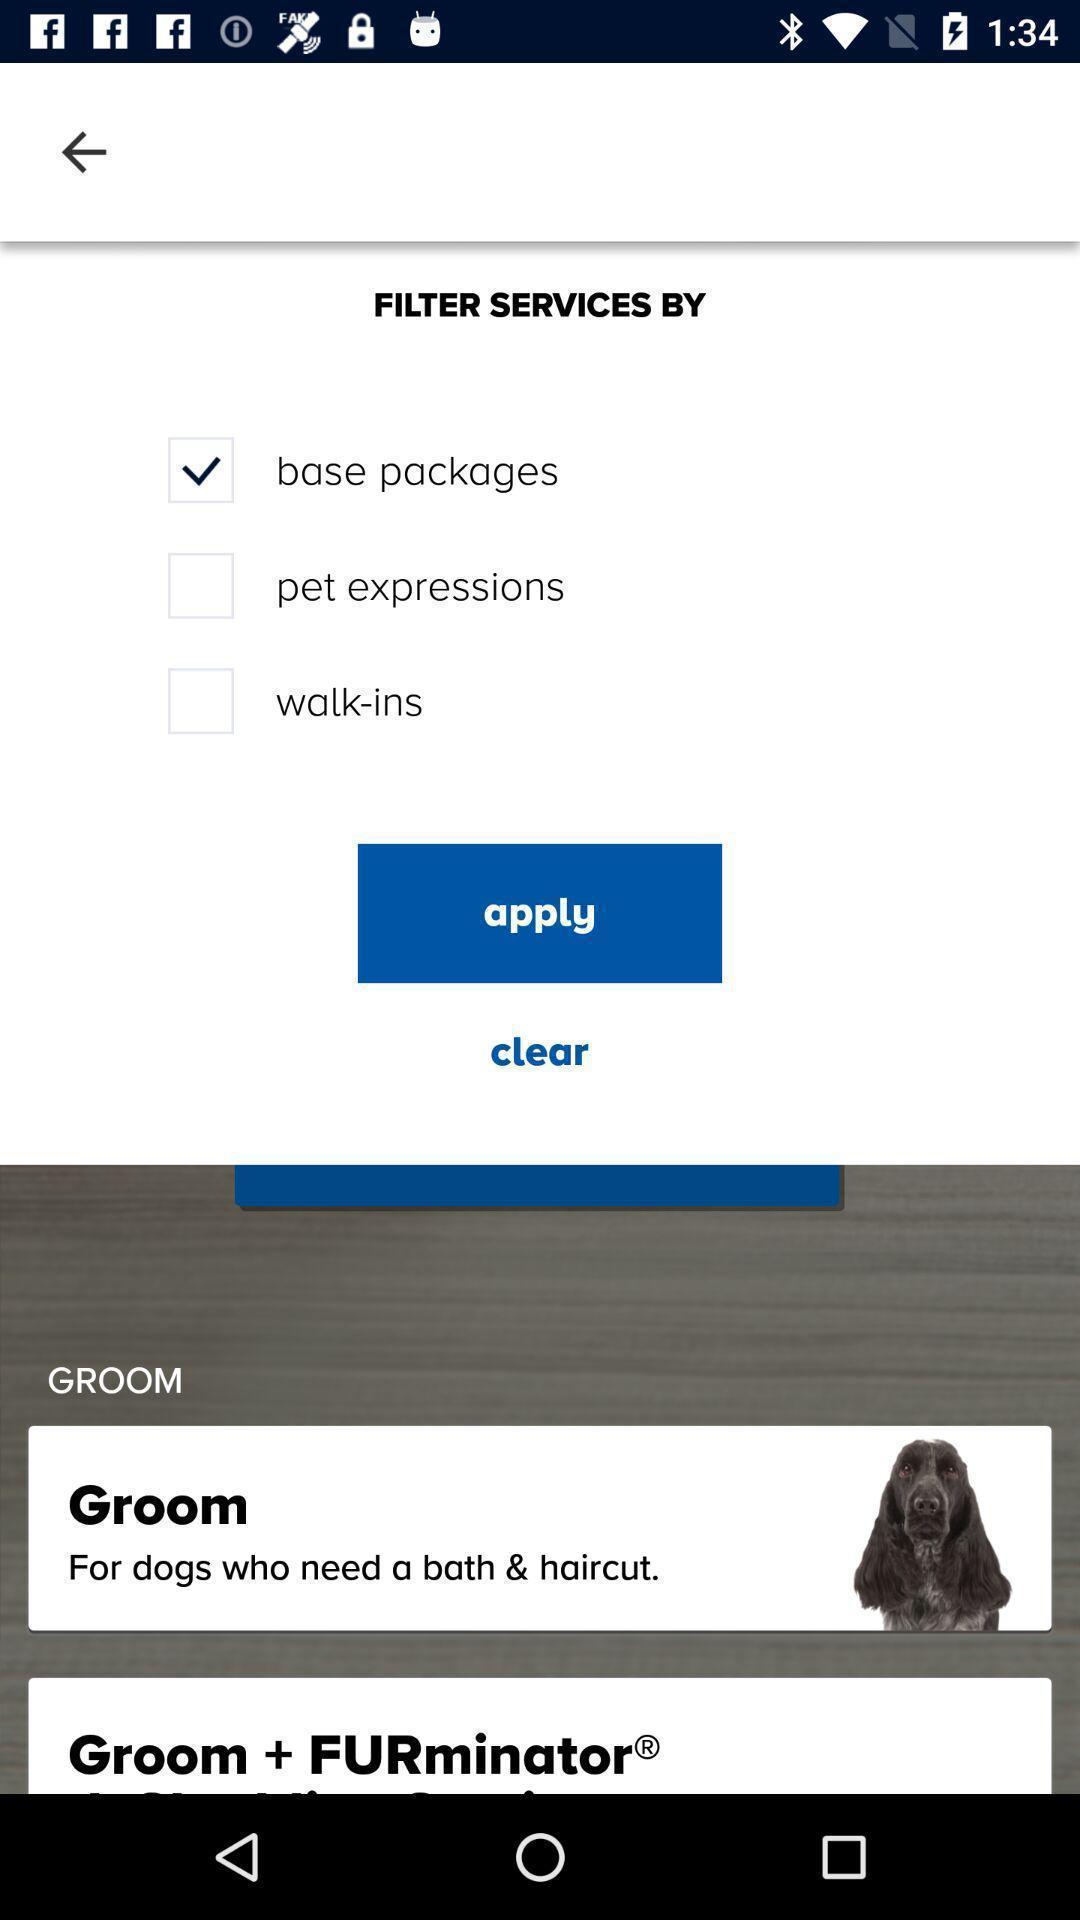Tell me about the visual elements in this screen capture. Pop up shows to apply a filter. 